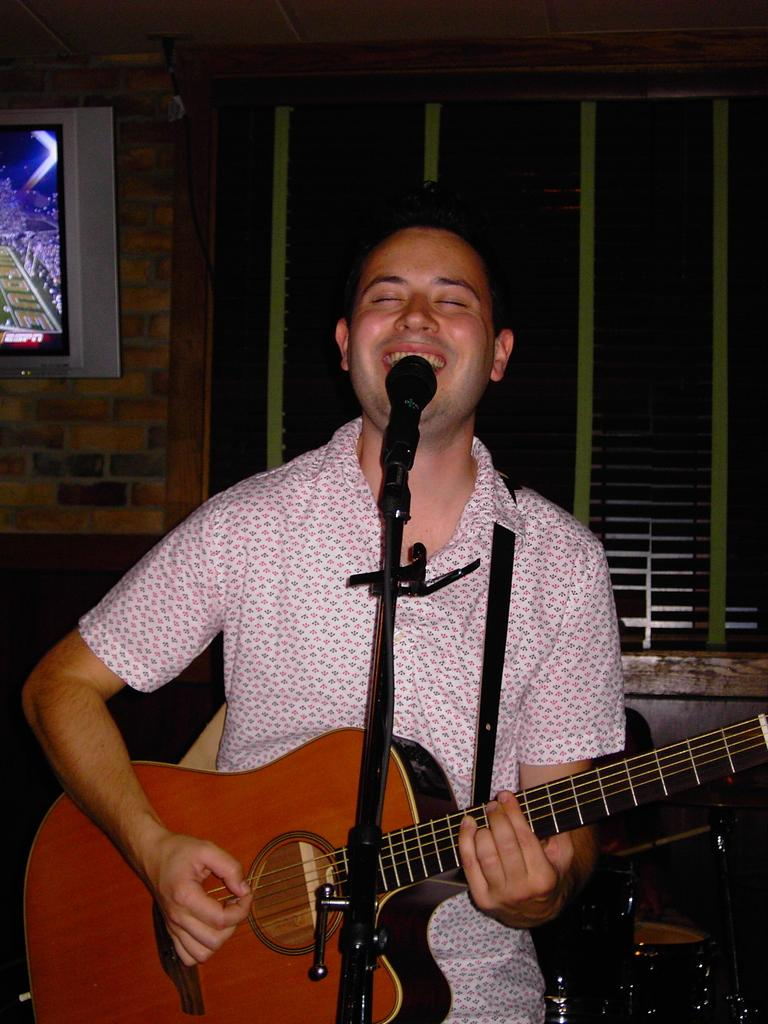What is the man in the image doing? The man is singing and playing a guitar. What is the man using to amplify his voice? The man is in front of a microphone. What can be seen in the background of the image? There are musical instruments and a television in the background, as well as a wall. What type of box is the man standing on in the image? There is no box present in the image; the man is standing on the floor. How many toes can be seen on the man's feet in the image? The image does not show the man's feet, so it is impossible to determine the number of toes. 